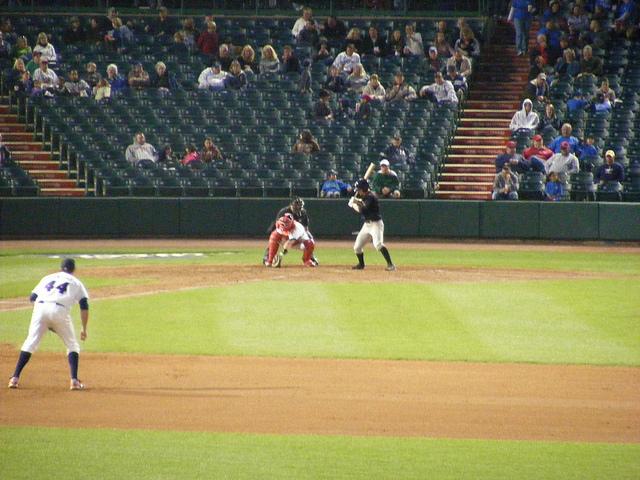What sport is being played?
Concise answer only. Baseball. Do more spectators have red shirts or blue shirts?
Write a very short answer. Blue. What number Jersey is the guy wearing?
Answer briefly. 44. What number is the pitcher wearing?
Quick response, please. 44. What is the person in white holding?
Short answer required. Glove. Are the players all on the same team?
Be succinct. No. 